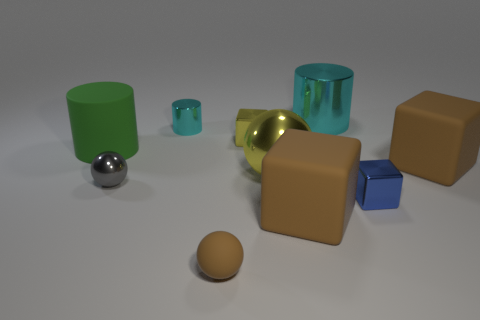Subtract all brown balls. How many balls are left? 2 Subtract all purple blocks. Subtract all purple balls. How many blocks are left? 4 Subtract all cylinders. How many objects are left? 7 Subtract 0 gray blocks. How many objects are left? 10 Subtract all tiny cyan cubes. Subtract all gray metallic objects. How many objects are left? 9 Add 7 brown blocks. How many brown blocks are left? 9 Add 7 big rubber balls. How many big rubber balls exist? 7 